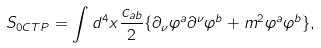Convert formula to latex. <formula><loc_0><loc_0><loc_500><loc_500>S _ { 0 C T P } = \int d ^ { 4 } x \frac { c _ { a b } } { 2 } \{ \partial _ { \nu } \varphi ^ { a } \partial ^ { \nu } \varphi ^ { b } + m ^ { 2 } \varphi ^ { a } \varphi ^ { b } \} ,</formula> 